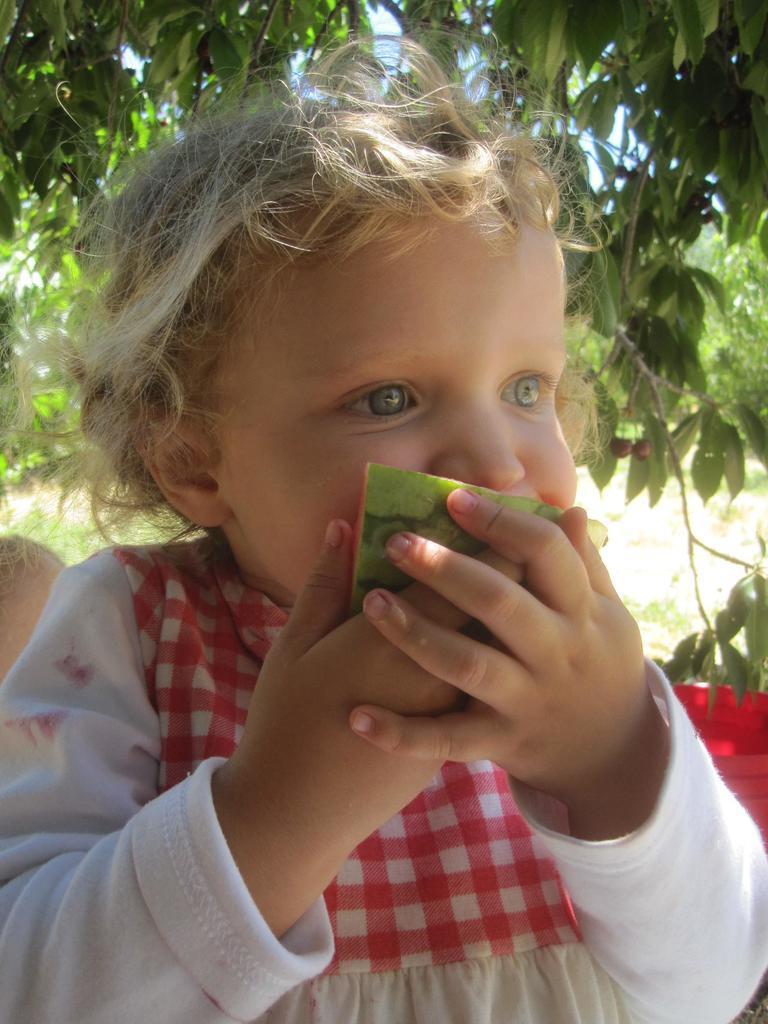Can you describe this image briefly? In this picture, we can see a child eating a fruit, we can see some trees and the sky in the background. 